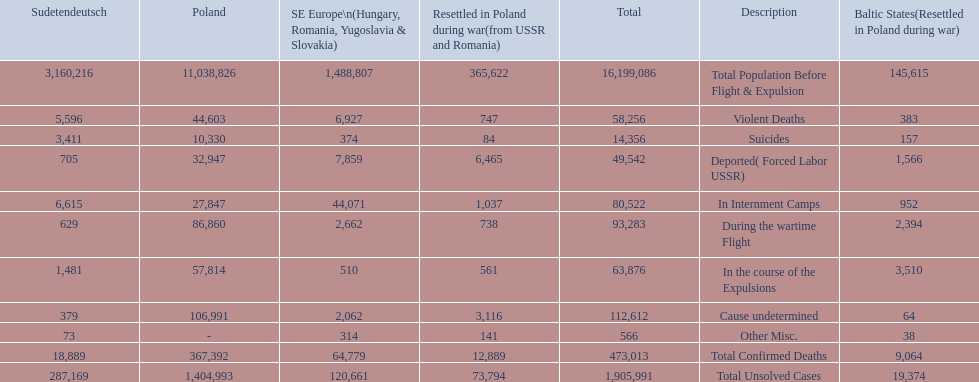What were the total number of confirmed deaths? 473,013. Of these, how many were violent? 58,256. 